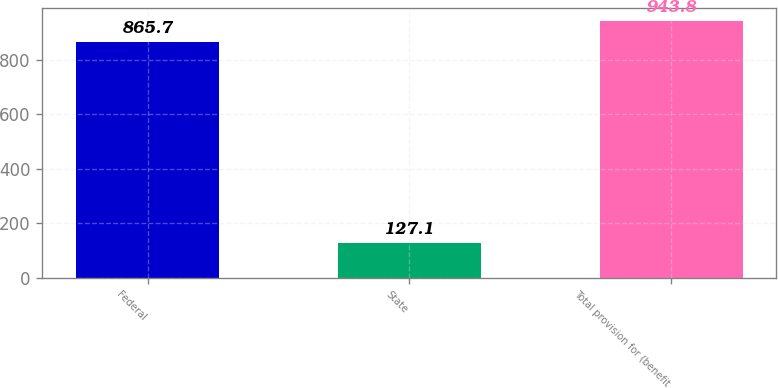Convert chart to OTSL. <chart><loc_0><loc_0><loc_500><loc_500><bar_chart><fcel>Federal<fcel>State<fcel>Total provision for (benefit<nl><fcel>865.7<fcel>127.1<fcel>943.8<nl></chart> 